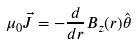Convert formula to latex. <formula><loc_0><loc_0><loc_500><loc_500>\mu _ { 0 } \vec { J } = - \frac { d } { d r } B _ { z } ( r ) \hat { \theta }</formula> 